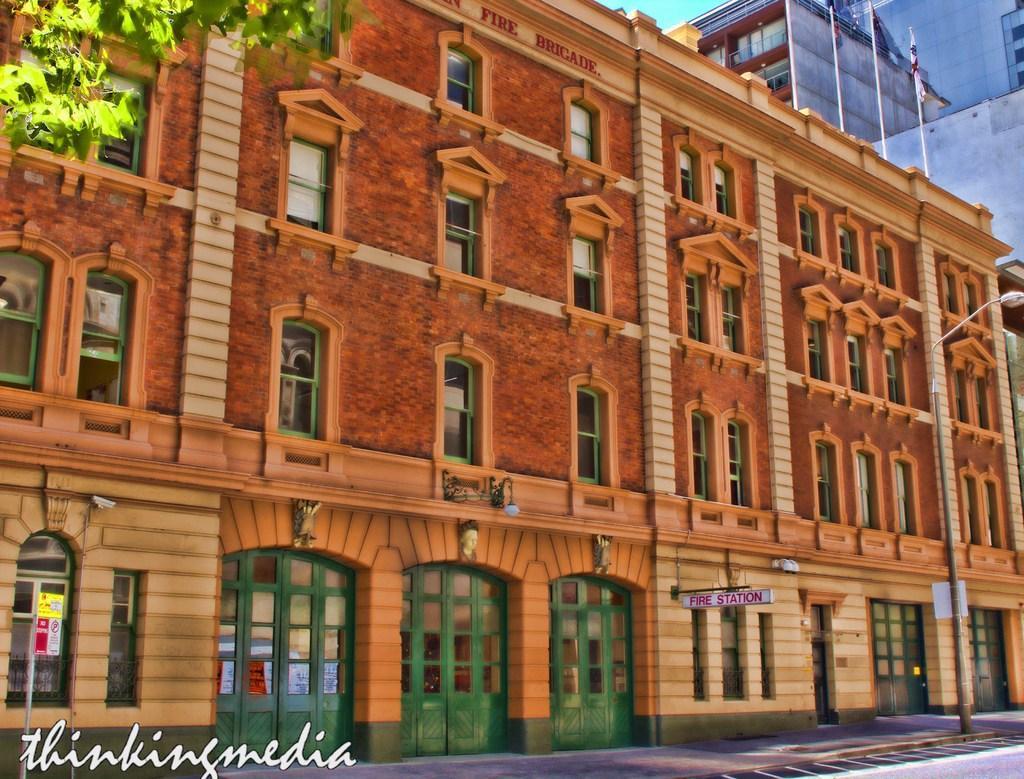In one or two sentences, can you explain what this image depicts? In this image we can see a building, on top of the building there are three flag posts, in front of the building on the payment there is a sign board and a lamp post, on the top right corner of the image there are leaves of a tree. 